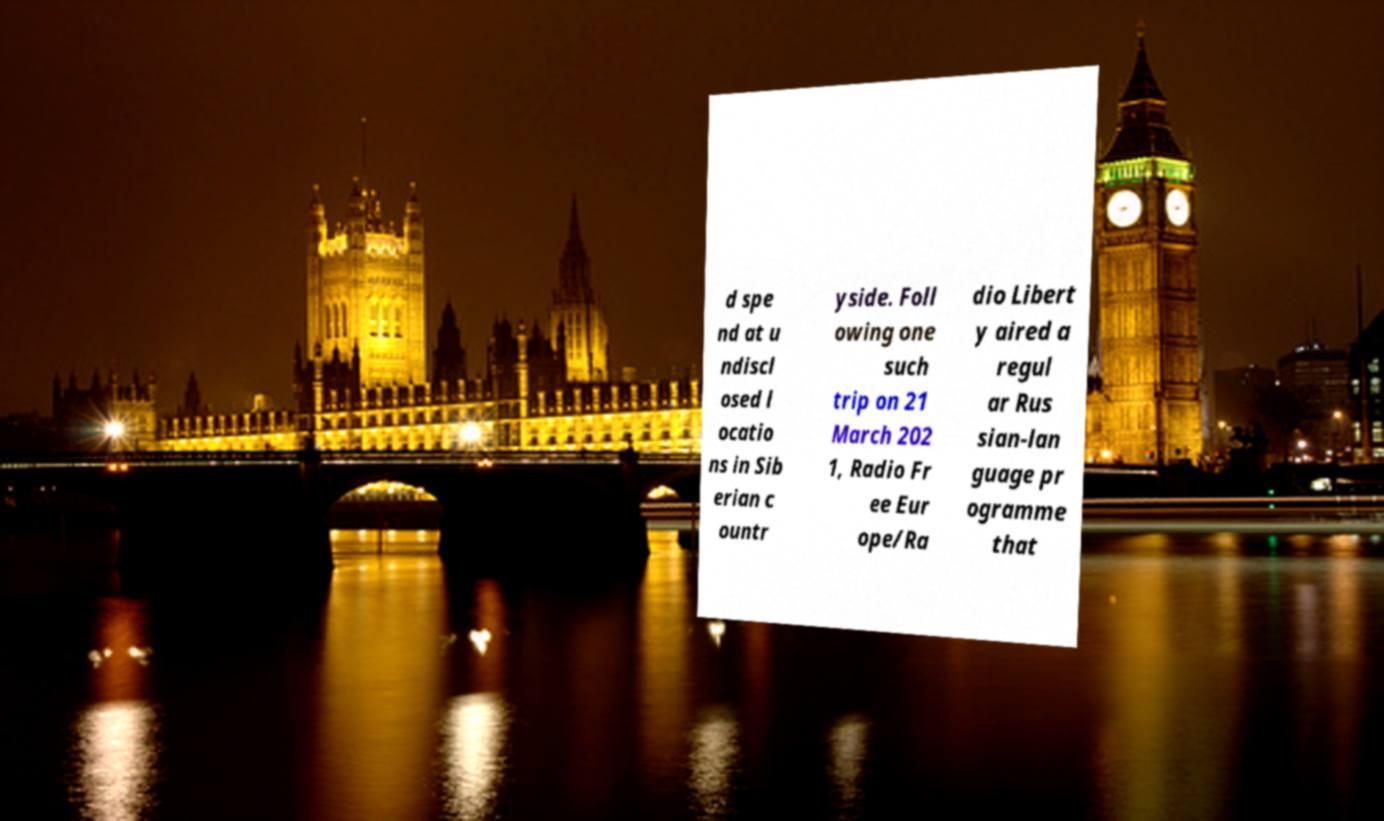Can you accurately transcribe the text from the provided image for me? d spe nd at u ndiscl osed l ocatio ns in Sib erian c ountr yside. Foll owing one such trip on 21 March 202 1, Radio Fr ee Eur ope/Ra dio Libert y aired a regul ar Rus sian-lan guage pr ogramme that 